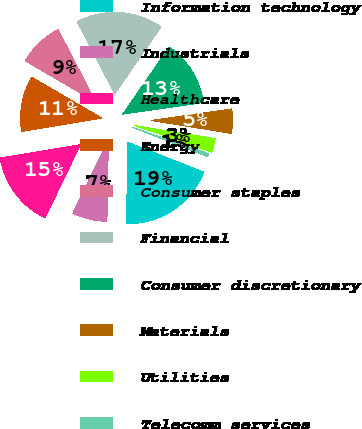<chart> <loc_0><loc_0><loc_500><loc_500><pie_chart><fcel>Information technology<fcel>Industrials<fcel>Healthcare<fcel>Energy<fcel>Consumer staples<fcel>Financial<fcel>Consumer discretionary<fcel>Materials<fcel>Utilities<fcel>Telecomm services<nl><fcel>19.34%<fcel>6.89%<fcel>15.19%<fcel>11.04%<fcel>8.96%<fcel>17.26%<fcel>13.11%<fcel>4.81%<fcel>2.74%<fcel>0.66%<nl></chart> 